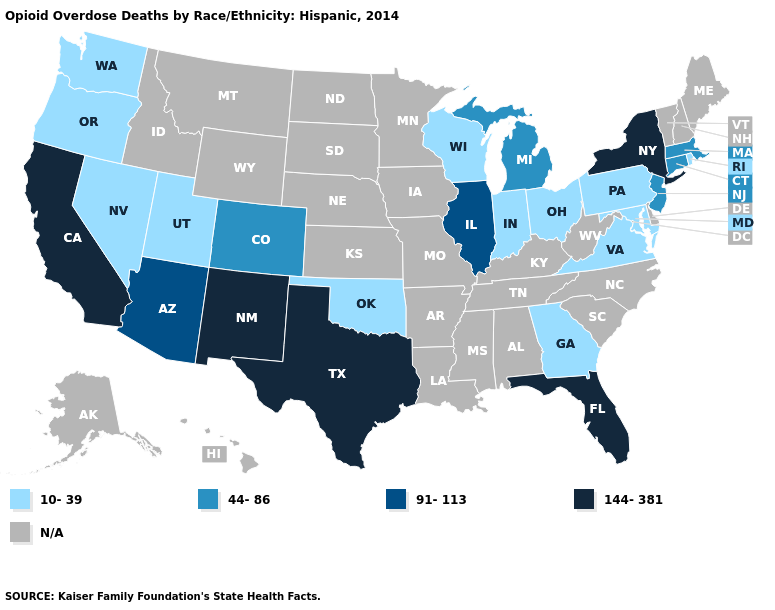Does Florida have the highest value in the USA?
Concise answer only. Yes. Is the legend a continuous bar?
Give a very brief answer. No. What is the lowest value in states that border Arkansas?
Answer briefly. 10-39. Name the states that have a value in the range 91-113?
Concise answer only. Arizona, Illinois. Does New Mexico have the highest value in the West?
Answer briefly. Yes. How many symbols are there in the legend?
Quick response, please. 5. Which states have the highest value in the USA?
Quick response, please. California, Florida, New Mexico, New York, Texas. What is the highest value in the MidWest ?
Concise answer only. 91-113. Name the states that have a value in the range 91-113?
Quick response, please. Arizona, Illinois. What is the value of Oklahoma?
Write a very short answer. 10-39. Name the states that have a value in the range 91-113?
Short answer required. Arizona, Illinois. 